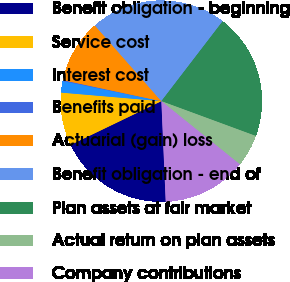Convert chart to OTSL. <chart><loc_0><loc_0><loc_500><loc_500><pie_chart><fcel>Benefit obligation - beginning<fcel>Service cost<fcel>Interest cost<fcel>Benefits paid<fcel>Actuarial (gain) loss<fcel>Benefit obligation - end of<fcel>Plan assets at fair market<fcel>Actual return on plan assets<fcel>Company contributions<nl><fcel>18.54%<fcel>8.51%<fcel>1.83%<fcel>0.16%<fcel>10.18%<fcel>21.88%<fcel>20.21%<fcel>5.17%<fcel>13.52%<nl></chart> 